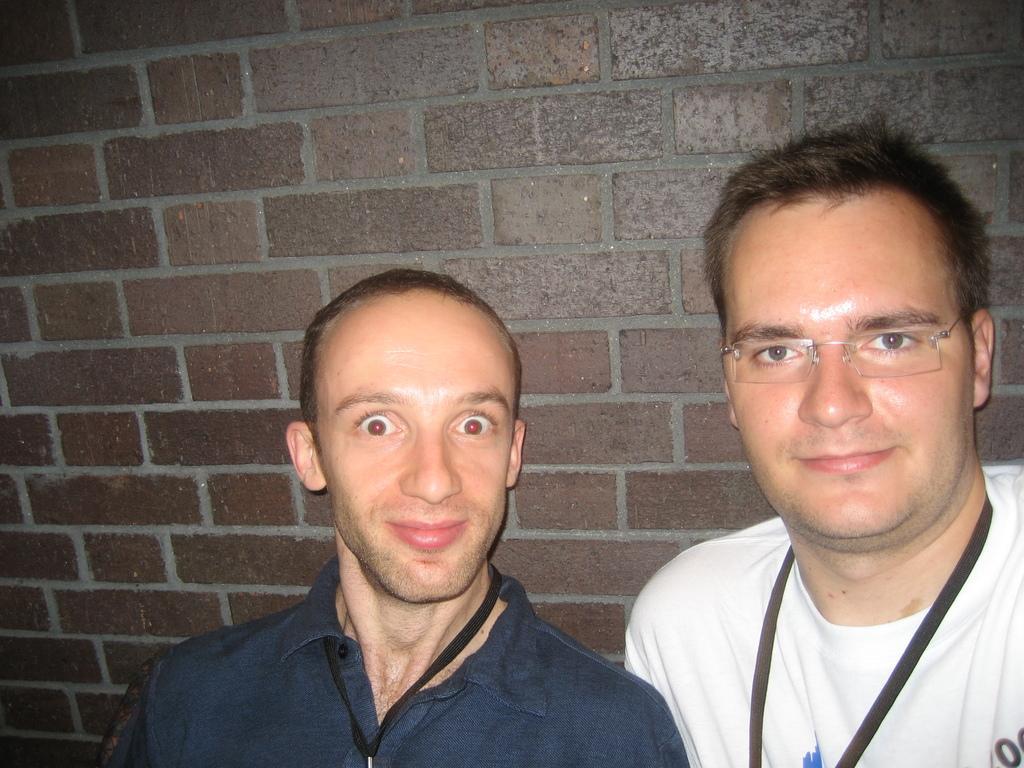Describe this image in one or two sentences. In this image in the foreground there are two persons who are standing, and in the background there is a wall. 